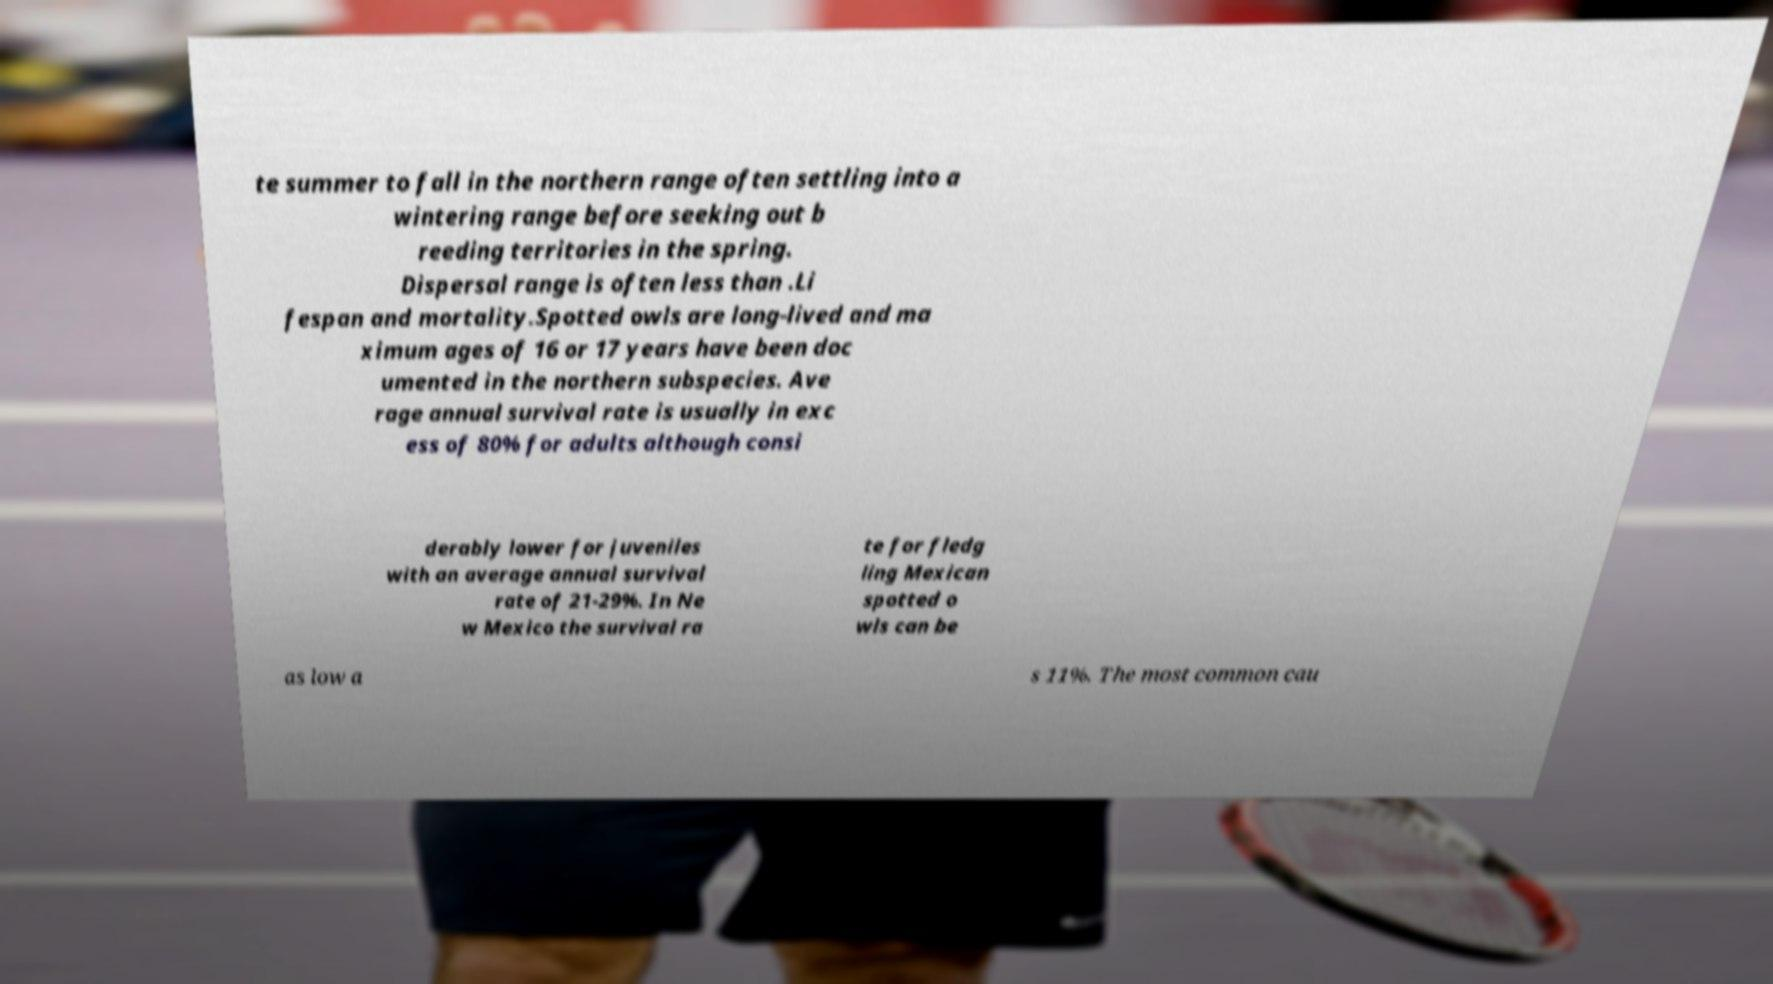Could you assist in decoding the text presented in this image and type it out clearly? te summer to fall in the northern range often settling into a wintering range before seeking out b reeding territories in the spring. Dispersal range is often less than .Li fespan and mortality.Spotted owls are long-lived and ma ximum ages of 16 or 17 years have been doc umented in the northern subspecies. Ave rage annual survival rate is usually in exc ess of 80% for adults although consi derably lower for juveniles with an average annual survival rate of 21-29%. In Ne w Mexico the survival ra te for fledg ling Mexican spotted o wls can be as low a s 11%. The most common cau 